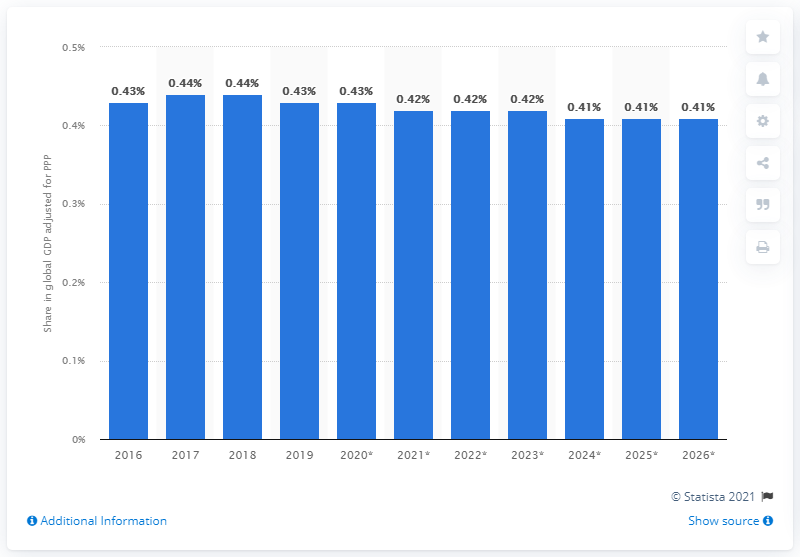List a handful of essential elements in this visual. Singapore's share of the global gross domestic product, adjusted for purchasing power parity (PPP), last adjusted in 2026. Singapore's share of the global gross domestic product, adjusted for Purchasing Power Parity, in 2019 was 0.43. 